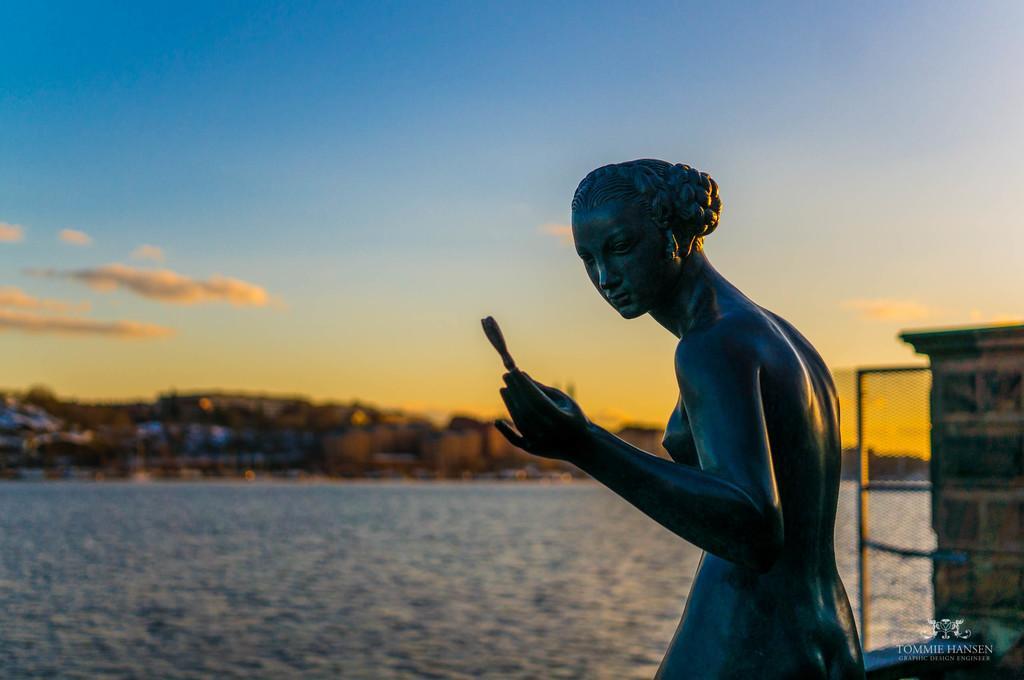Describe this image in one or two sentences. In this image, we can see a statue and in the background, there are buildings and trees and we can see a wall and there is water. At the top, there are clouds in the sky and at the bottom, there is some text and a logo. 